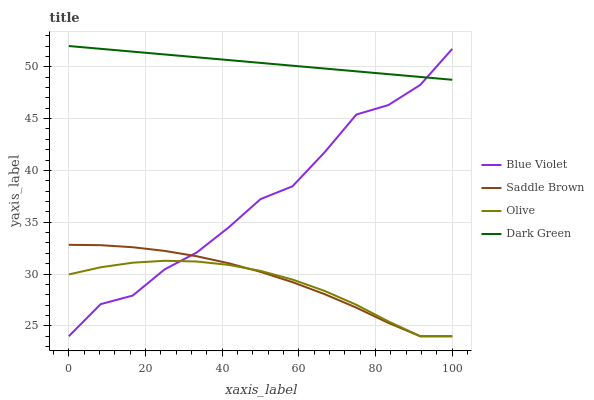Does Saddle Brown have the minimum area under the curve?
Answer yes or no. No. Does Saddle Brown have the maximum area under the curve?
Answer yes or no. No. Is Saddle Brown the smoothest?
Answer yes or no. No. Is Saddle Brown the roughest?
Answer yes or no. No. Does Dark Green have the lowest value?
Answer yes or no. No. Does Saddle Brown have the highest value?
Answer yes or no. No. Is Olive less than Dark Green?
Answer yes or no. Yes. Is Dark Green greater than Olive?
Answer yes or no. Yes. Does Olive intersect Dark Green?
Answer yes or no. No. 